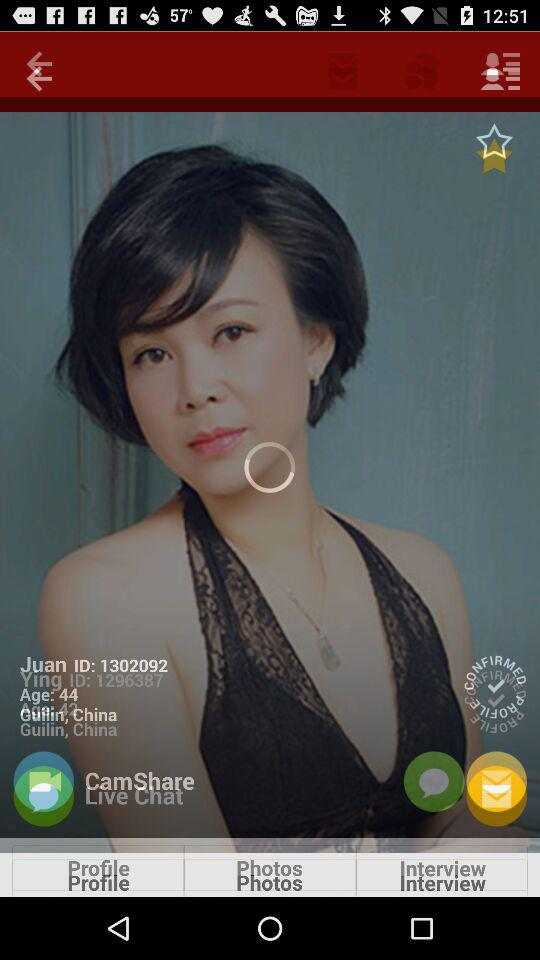What is the ID of Juan? The ID of Juan is 1302092. 